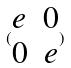Convert formula to latex. <formula><loc_0><loc_0><loc_500><loc_500>( \begin{matrix} e & 0 \\ 0 & e \end{matrix} )</formula> 